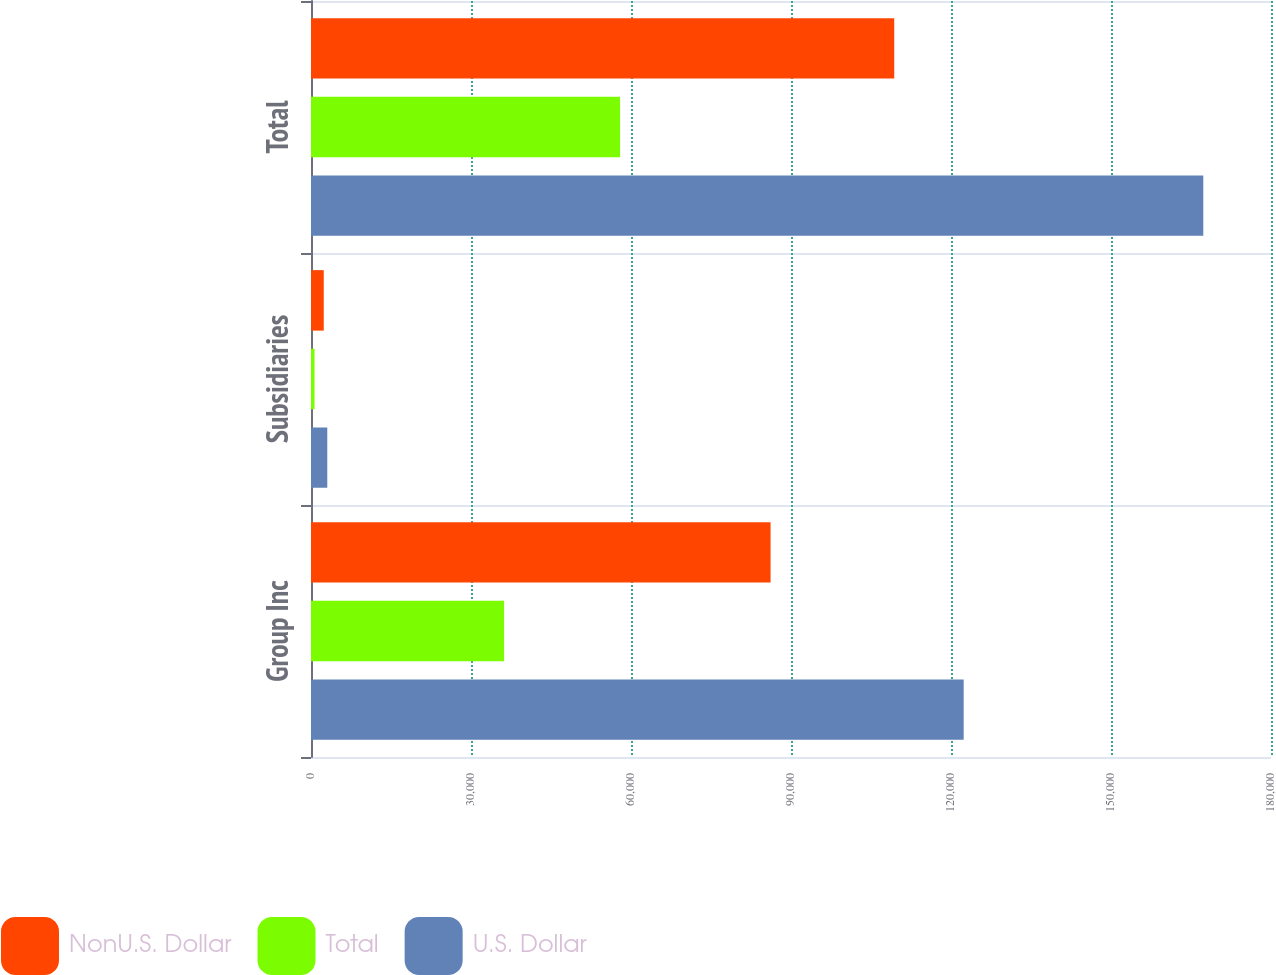Convert chart to OTSL. <chart><loc_0><loc_0><loc_500><loc_500><stacked_bar_chart><ecel><fcel>Group Inc<fcel>Subsidiaries<fcel>Total<nl><fcel>NonU.S. Dollar<fcel>86170<fcel>2391<fcel>109355<nl><fcel>Total<fcel>36207<fcel>662<fcel>57950<nl><fcel>U.S. Dollar<fcel>122377<fcel>3053<fcel>167305<nl></chart> 